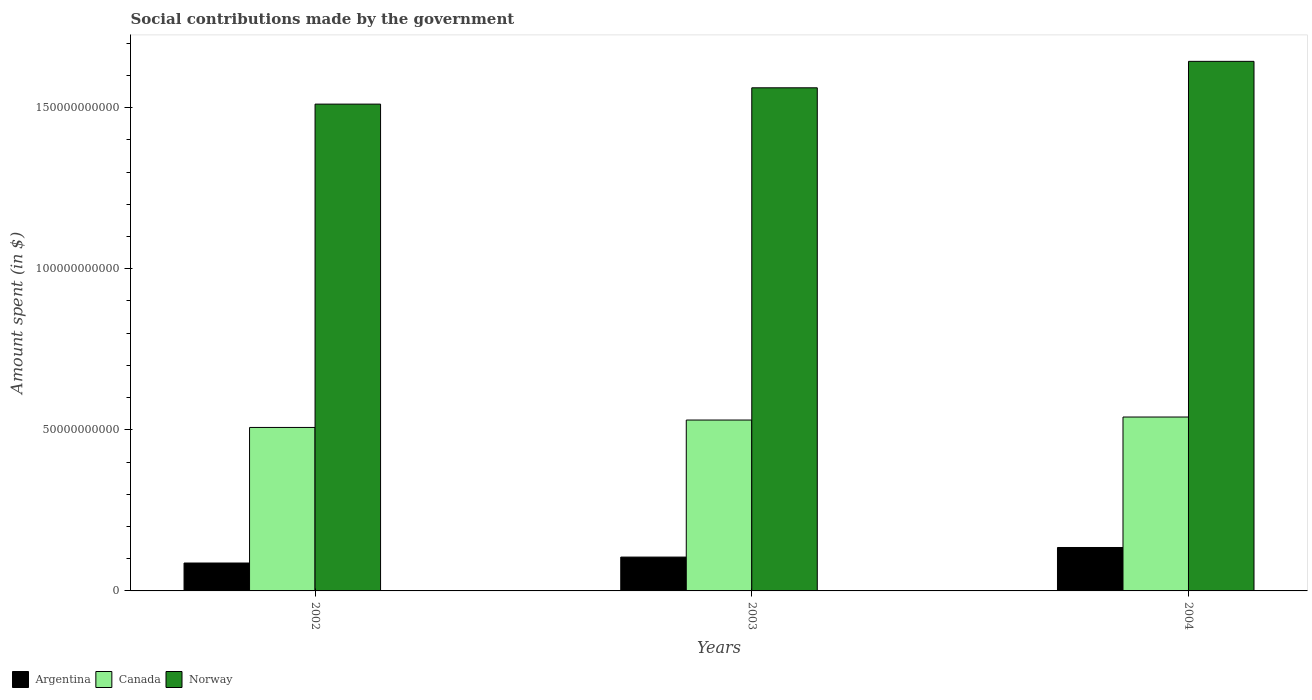How many groups of bars are there?
Ensure brevity in your answer.  3. Are the number of bars per tick equal to the number of legend labels?
Your response must be concise. Yes. How many bars are there on the 2nd tick from the left?
Offer a very short reply. 3. What is the label of the 3rd group of bars from the left?
Your response must be concise. 2004. In how many cases, is the number of bars for a given year not equal to the number of legend labels?
Make the answer very short. 0. What is the amount spent on social contributions in Norway in 2004?
Give a very brief answer. 1.64e+11. Across all years, what is the maximum amount spent on social contributions in Norway?
Provide a succinct answer. 1.64e+11. Across all years, what is the minimum amount spent on social contributions in Norway?
Ensure brevity in your answer.  1.51e+11. In which year was the amount spent on social contributions in Canada minimum?
Give a very brief answer. 2002. What is the total amount spent on social contributions in Canada in the graph?
Keep it short and to the point. 1.58e+11. What is the difference between the amount spent on social contributions in Canada in 2003 and that in 2004?
Offer a terse response. -9.36e+08. What is the difference between the amount spent on social contributions in Norway in 2003 and the amount spent on social contributions in Canada in 2002?
Ensure brevity in your answer.  1.05e+11. What is the average amount spent on social contributions in Norway per year?
Offer a terse response. 1.57e+11. In the year 2003, what is the difference between the amount spent on social contributions in Norway and amount spent on social contributions in Argentina?
Your answer should be compact. 1.46e+11. What is the ratio of the amount spent on social contributions in Argentina in 2003 to that in 2004?
Give a very brief answer. 0.78. Is the amount spent on social contributions in Norway in 2002 less than that in 2003?
Provide a short and direct response. Yes. What is the difference between the highest and the second highest amount spent on social contributions in Argentina?
Keep it short and to the point. 2.98e+09. What is the difference between the highest and the lowest amount spent on social contributions in Argentina?
Give a very brief answer. 4.82e+09. In how many years, is the amount spent on social contributions in Canada greater than the average amount spent on social contributions in Canada taken over all years?
Your answer should be very brief. 2. What does the 1st bar from the left in 2003 represents?
Ensure brevity in your answer.  Argentina. Is it the case that in every year, the sum of the amount spent on social contributions in Norway and amount spent on social contributions in Argentina is greater than the amount spent on social contributions in Canada?
Keep it short and to the point. Yes. How many years are there in the graph?
Offer a terse response. 3. Are the values on the major ticks of Y-axis written in scientific E-notation?
Offer a very short reply. No. Does the graph contain grids?
Provide a succinct answer. No. How many legend labels are there?
Offer a very short reply. 3. How are the legend labels stacked?
Your answer should be compact. Horizontal. What is the title of the graph?
Keep it short and to the point. Social contributions made by the government. What is the label or title of the X-axis?
Keep it short and to the point. Years. What is the label or title of the Y-axis?
Offer a terse response. Amount spent (in $). What is the Amount spent (in $) of Argentina in 2002?
Ensure brevity in your answer.  8.66e+09. What is the Amount spent (in $) of Canada in 2002?
Your answer should be compact. 5.07e+1. What is the Amount spent (in $) of Norway in 2002?
Your answer should be very brief. 1.51e+11. What is the Amount spent (in $) in Argentina in 2003?
Your answer should be compact. 1.05e+1. What is the Amount spent (in $) of Canada in 2003?
Your answer should be compact. 5.30e+1. What is the Amount spent (in $) in Norway in 2003?
Offer a terse response. 1.56e+11. What is the Amount spent (in $) of Argentina in 2004?
Offer a terse response. 1.35e+1. What is the Amount spent (in $) of Canada in 2004?
Keep it short and to the point. 5.40e+1. What is the Amount spent (in $) in Norway in 2004?
Make the answer very short. 1.64e+11. Across all years, what is the maximum Amount spent (in $) of Argentina?
Your response must be concise. 1.35e+1. Across all years, what is the maximum Amount spent (in $) in Canada?
Offer a terse response. 5.40e+1. Across all years, what is the maximum Amount spent (in $) in Norway?
Offer a terse response. 1.64e+11. Across all years, what is the minimum Amount spent (in $) in Argentina?
Provide a succinct answer. 8.66e+09. Across all years, what is the minimum Amount spent (in $) of Canada?
Your response must be concise. 5.07e+1. Across all years, what is the minimum Amount spent (in $) of Norway?
Keep it short and to the point. 1.51e+11. What is the total Amount spent (in $) in Argentina in the graph?
Ensure brevity in your answer.  3.26e+1. What is the total Amount spent (in $) of Canada in the graph?
Offer a terse response. 1.58e+11. What is the total Amount spent (in $) of Norway in the graph?
Offer a very short reply. 4.72e+11. What is the difference between the Amount spent (in $) of Argentina in 2002 and that in 2003?
Your response must be concise. -1.84e+09. What is the difference between the Amount spent (in $) of Canada in 2002 and that in 2003?
Your answer should be compact. -2.30e+09. What is the difference between the Amount spent (in $) of Norway in 2002 and that in 2003?
Give a very brief answer. -5.06e+09. What is the difference between the Amount spent (in $) of Argentina in 2002 and that in 2004?
Keep it short and to the point. -4.82e+09. What is the difference between the Amount spent (in $) in Canada in 2002 and that in 2004?
Ensure brevity in your answer.  -3.24e+09. What is the difference between the Amount spent (in $) in Norway in 2002 and that in 2004?
Give a very brief answer. -1.33e+1. What is the difference between the Amount spent (in $) of Argentina in 2003 and that in 2004?
Provide a short and direct response. -2.98e+09. What is the difference between the Amount spent (in $) in Canada in 2003 and that in 2004?
Offer a very short reply. -9.36e+08. What is the difference between the Amount spent (in $) of Norway in 2003 and that in 2004?
Ensure brevity in your answer.  -8.21e+09. What is the difference between the Amount spent (in $) in Argentina in 2002 and the Amount spent (in $) in Canada in 2003?
Keep it short and to the point. -4.44e+1. What is the difference between the Amount spent (in $) of Argentina in 2002 and the Amount spent (in $) of Norway in 2003?
Provide a succinct answer. -1.47e+11. What is the difference between the Amount spent (in $) of Canada in 2002 and the Amount spent (in $) of Norway in 2003?
Provide a short and direct response. -1.05e+11. What is the difference between the Amount spent (in $) of Argentina in 2002 and the Amount spent (in $) of Canada in 2004?
Provide a succinct answer. -4.53e+1. What is the difference between the Amount spent (in $) in Argentina in 2002 and the Amount spent (in $) in Norway in 2004?
Provide a short and direct response. -1.56e+11. What is the difference between the Amount spent (in $) of Canada in 2002 and the Amount spent (in $) of Norway in 2004?
Provide a succinct answer. -1.14e+11. What is the difference between the Amount spent (in $) of Argentina in 2003 and the Amount spent (in $) of Canada in 2004?
Make the answer very short. -4.35e+1. What is the difference between the Amount spent (in $) in Argentina in 2003 and the Amount spent (in $) in Norway in 2004?
Your answer should be compact. -1.54e+11. What is the difference between the Amount spent (in $) of Canada in 2003 and the Amount spent (in $) of Norway in 2004?
Keep it short and to the point. -1.11e+11. What is the average Amount spent (in $) of Argentina per year?
Provide a succinct answer. 1.09e+1. What is the average Amount spent (in $) in Canada per year?
Give a very brief answer. 5.26e+1. What is the average Amount spent (in $) in Norway per year?
Offer a terse response. 1.57e+11. In the year 2002, what is the difference between the Amount spent (in $) in Argentina and Amount spent (in $) in Canada?
Provide a short and direct response. -4.21e+1. In the year 2002, what is the difference between the Amount spent (in $) in Argentina and Amount spent (in $) in Norway?
Your answer should be compact. -1.42e+11. In the year 2002, what is the difference between the Amount spent (in $) in Canada and Amount spent (in $) in Norway?
Ensure brevity in your answer.  -1.00e+11. In the year 2003, what is the difference between the Amount spent (in $) in Argentina and Amount spent (in $) in Canada?
Your answer should be very brief. -4.25e+1. In the year 2003, what is the difference between the Amount spent (in $) in Argentina and Amount spent (in $) in Norway?
Keep it short and to the point. -1.46e+11. In the year 2003, what is the difference between the Amount spent (in $) in Canada and Amount spent (in $) in Norway?
Offer a very short reply. -1.03e+11. In the year 2004, what is the difference between the Amount spent (in $) in Argentina and Amount spent (in $) in Canada?
Give a very brief answer. -4.05e+1. In the year 2004, what is the difference between the Amount spent (in $) of Argentina and Amount spent (in $) of Norway?
Offer a very short reply. -1.51e+11. In the year 2004, what is the difference between the Amount spent (in $) of Canada and Amount spent (in $) of Norway?
Provide a succinct answer. -1.10e+11. What is the ratio of the Amount spent (in $) of Argentina in 2002 to that in 2003?
Provide a succinct answer. 0.82. What is the ratio of the Amount spent (in $) of Canada in 2002 to that in 2003?
Keep it short and to the point. 0.96. What is the ratio of the Amount spent (in $) of Norway in 2002 to that in 2003?
Your answer should be compact. 0.97. What is the ratio of the Amount spent (in $) of Argentina in 2002 to that in 2004?
Offer a very short reply. 0.64. What is the ratio of the Amount spent (in $) in Canada in 2002 to that in 2004?
Ensure brevity in your answer.  0.94. What is the ratio of the Amount spent (in $) of Norway in 2002 to that in 2004?
Offer a terse response. 0.92. What is the ratio of the Amount spent (in $) in Argentina in 2003 to that in 2004?
Offer a terse response. 0.78. What is the ratio of the Amount spent (in $) of Canada in 2003 to that in 2004?
Ensure brevity in your answer.  0.98. What is the ratio of the Amount spent (in $) in Norway in 2003 to that in 2004?
Ensure brevity in your answer.  0.95. What is the difference between the highest and the second highest Amount spent (in $) of Argentina?
Make the answer very short. 2.98e+09. What is the difference between the highest and the second highest Amount spent (in $) in Canada?
Your answer should be very brief. 9.36e+08. What is the difference between the highest and the second highest Amount spent (in $) of Norway?
Keep it short and to the point. 8.21e+09. What is the difference between the highest and the lowest Amount spent (in $) in Argentina?
Make the answer very short. 4.82e+09. What is the difference between the highest and the lowest Amount spent (in $) of Canada?
Keep it short and to the point. 3.24e+09. What is the difference between the highest and the lowest Amount spent (in $) in Norway?
Keep it short and to the point. 1.33e+1. 